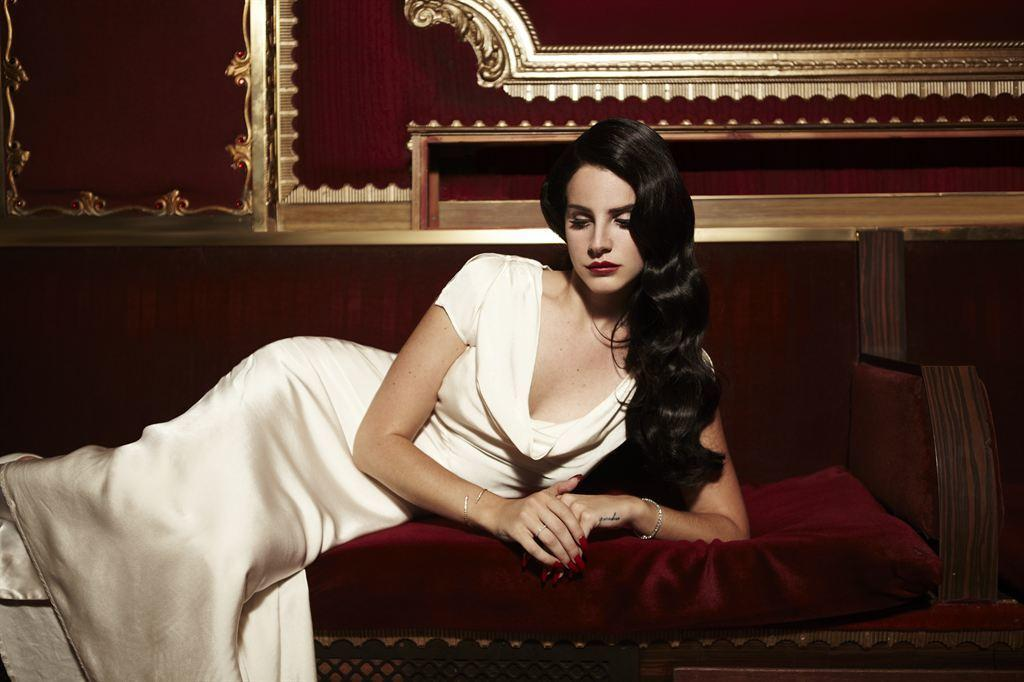Who or what is in the image? There is a person in the image. What is the person doing or where are they located? The person is on a bed. What is the person wearing? The person is wearing clothes. Can you describe any patterns or designs in the image? There are designs at the top of the image. What type of jewel is the person holding in the image? There is no jewel present in the image. How does the cork affect the person's position on the bed? There is no cork mentioned in the image, and it does not affect the person's position on the bed. 